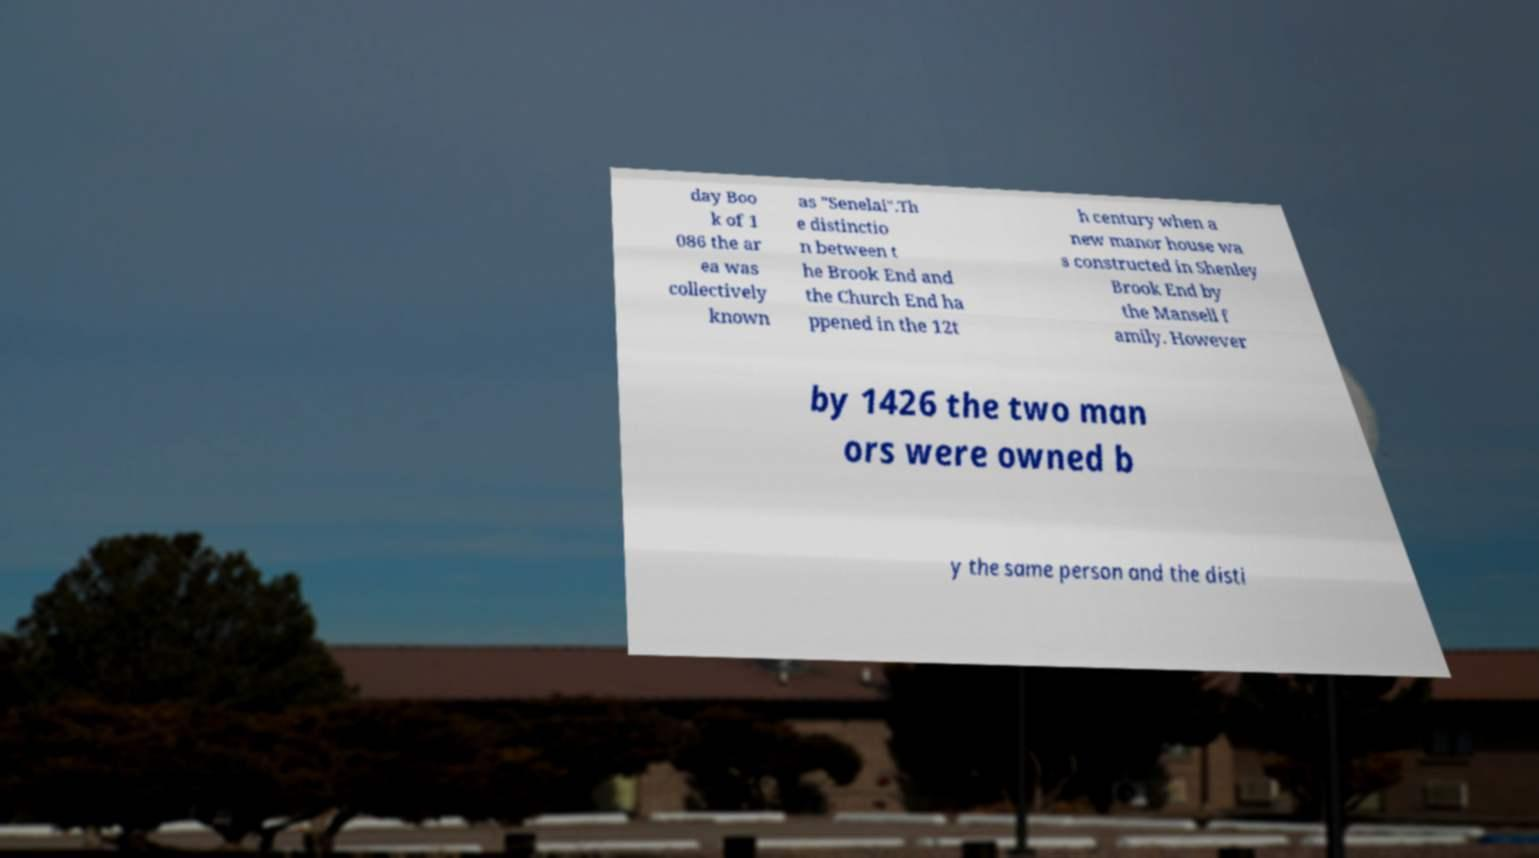I need the written content from this picture converted into text. Can you do that? day Boo k of 1 086 the ar ea was collectively known as "Senelai".Th e distinctio n between t he Brook End and the Church End ha ppened in the 12t h century when a new manor house wa s constructed in Shenley Brook End by the Mansell f amily. However by 1426 the two man ors were owned b y the same person and the disti 